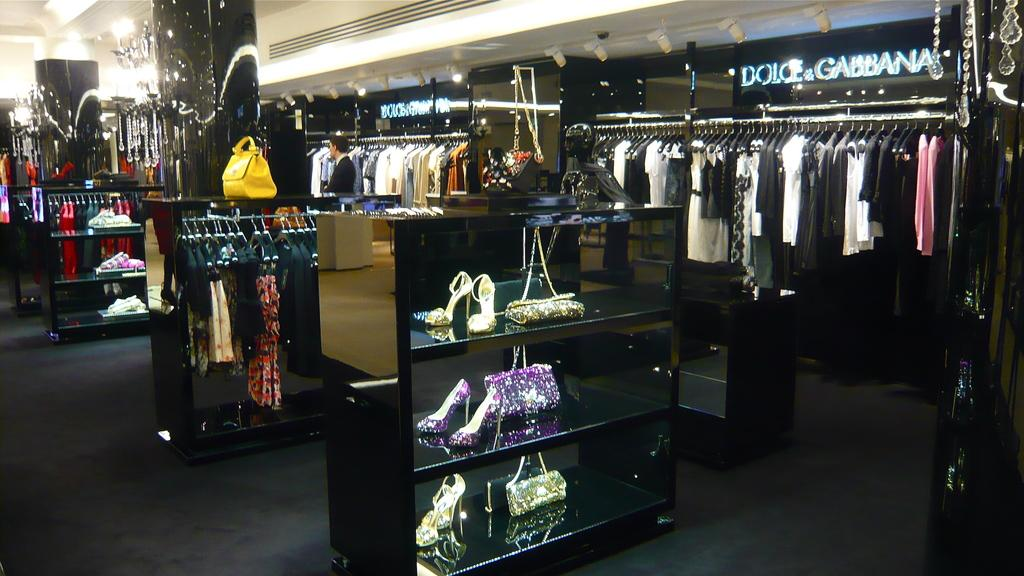<image>
Render a clear and concise summary of the photo. A clothing store that offers Dolce & Gabbana products 